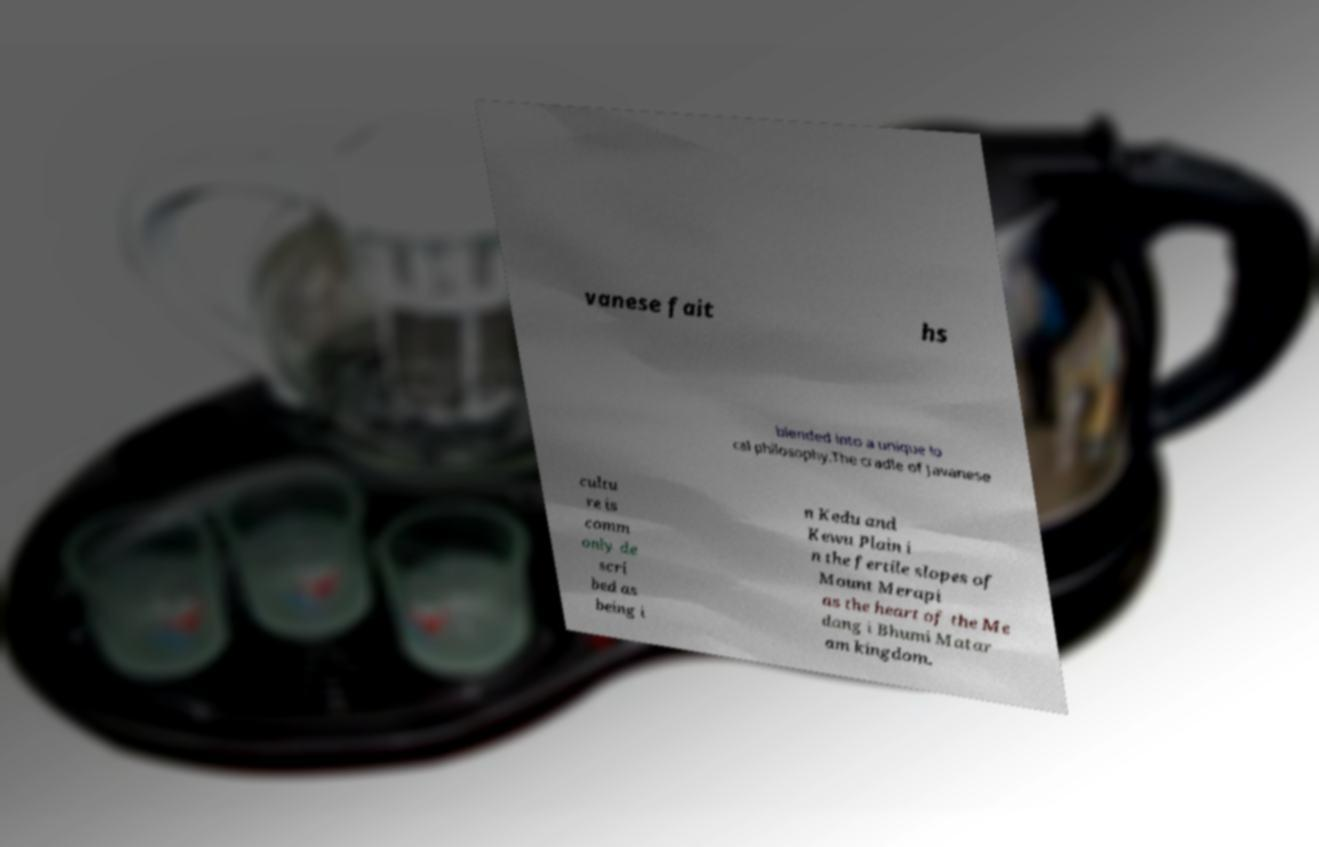For documentation purposes, I need the text within this image transcribed. Could you provide that? vanese fait hs blended into a unique lo cal philosophy.The cradle of Javanese cultu re is comm only de scri bed as being i n Kedu and Kewu Plain i n the fertile slopes of Mount Merapi as the heart of the Me dang i Bhumi Matar am kingdom. 